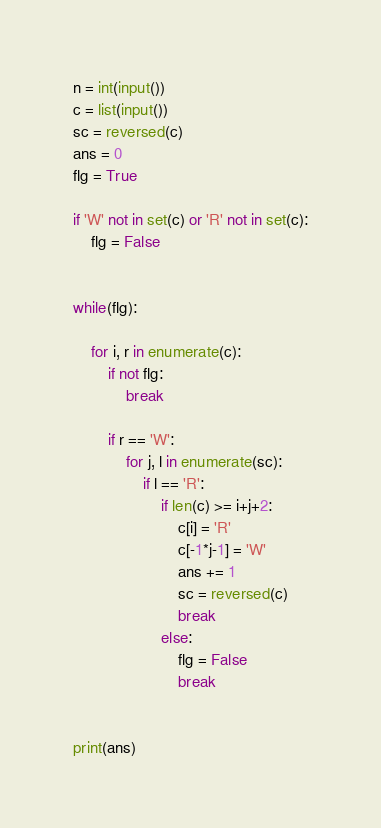Convert code to text. <code><loc_0><loc_0><loc_500><loc_500><_Python_>n = int(input())
c = list(input())
sc = reversed(c)
ans = 0
flg = True

if 'W' not in set(c) or 'R' not in set(c):
    flg = False


while(flg):

    for i, r in enumerate(c):
        if not flg:
            break

        if r == 'W':
            for j, l in enumerate(sc):
                if l == 'R':
                    if len(c) >= i+j+2:
                        c[i] = 'R'
                        c[-1*j-1] = 'W'
                        ans += 1
                        sc = reversed(c)
                        break
                    else:
                        flg = False
                        break


print(ans)

</code> 